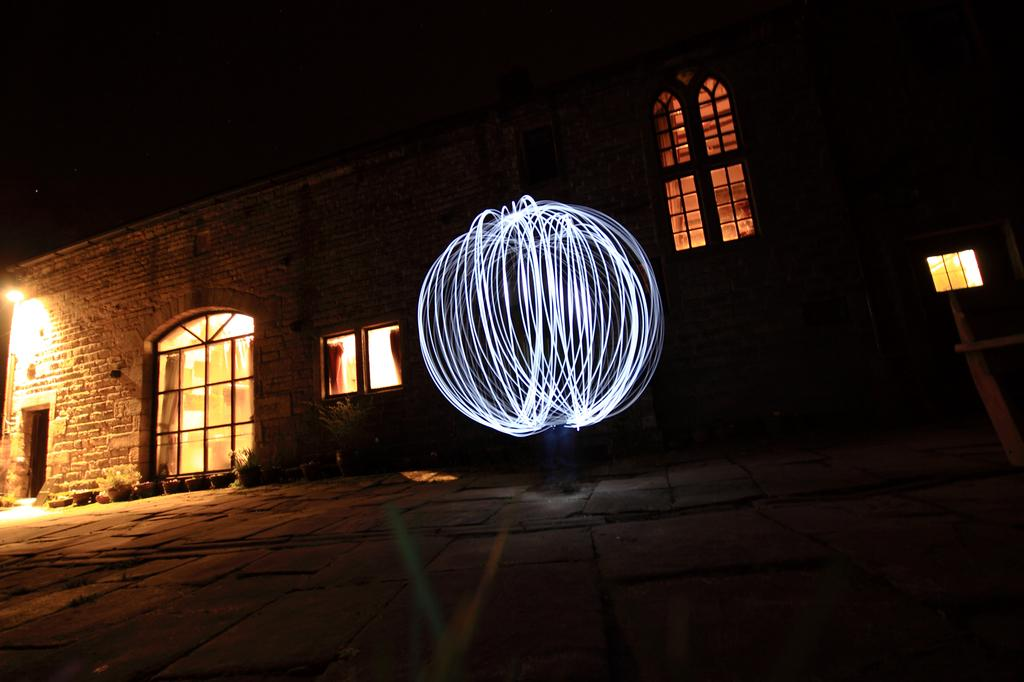What type of structure is present in the image? There is a building in the picture. What feature can be observed on the building? The building has glass windows. What can be seen inside the building? Lights are visible in the picture. How would you describe the overall lighting in the image? The background of the image is dark. How many eggs are visible on the building's roof in the image? There are no eggs visible on the building's roof in the image. What time of day is it in the image, based on the hour displayed on the building's clock? There is no clock present in the image to determine the time of day. 